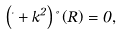<formula> <loc_0><loc_0><loc_500><loc_500>\left ( \Delta + k ^ { 2 } \right ) \Psi \left ( { R } \right ) = 0 ,</formula> 